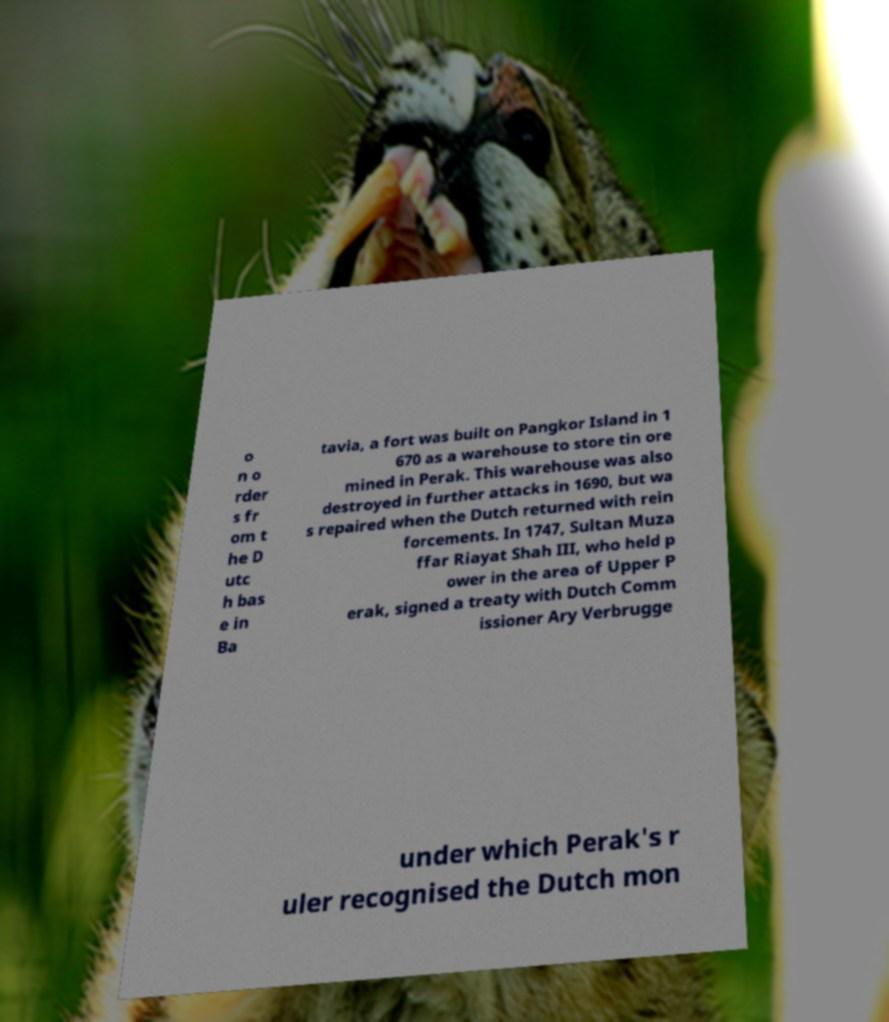Could you extract and type out the text from this image? o n o rder s fr om t he D utc h bas e in Ba tavia, a fort was built on Pangkor Island in 1 670 as a warehouse to store tin ore mined in Perak. This warehouse was also destroyed in further attacks in 1690, but wa s repaired when the Dutch returned with rein forcements. In 1747, Sultan Muza ffar Riayat Shah III, who held p ower in the area of Upper P erak, signed a treaty with Dutch Comm issioner Ary Verbrugge under which Perak's r uler recognised the Dutch mon 